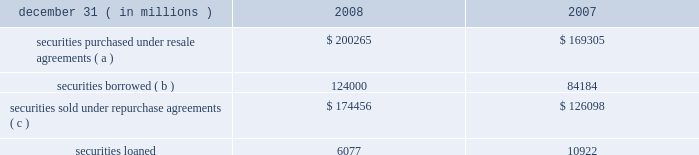Jpmorgan chase & co .
/ 2008 annual report 175jpmorgan chase & co .
/ 2008 annual report 175jpmorgan chase & co .
/ 2008 annual report 175jpmorgan chase & co .
/ 2008 annual report 175jpmorgan chase & co .
/ 2008 annual report 175 securities borrowed and securities lent are recorded at the amount of cash collateral advanced or received .
Securities borrowed consist primarily of government and equity securities .
Jpmorgan chase moni- tors the market value of the securities borrowed and lent on a daily basis and calls for additional collateral when appropriate .
Fees received or paid in connection with securities borrowed and lent are recorded in interest income or interest expense .
The table details the components of collateralized financings. .
( a ) includes resale agreements of $ 20.8 billion and $ 19.1 billion accounted for at fair value at december 31 , 2008 and 2007 , respectively .
( b ) includes securities borrowed of $ 3.4 billion accounted for at fair value at december 31 , 2008 .
( c ) includes repurchase agreements of $ 3.0 billion and $ 5.8 billion accounted for at fair value at december 31 , 2008 and 2007 , respectively .
Jpmorgan chase pledges certain financial instruments it owns to col- lateralize repurchase agreements and other securities financings .
Pledged securities that can be sold or repledged by the secured party are identified as financial instruments owned ( pledged to various parties ) on the consolidated balance sheets .
At december 31 , 2008 , the firm received securities as collateral that could be repledged , delivered or otherwise used with a fair value of approximately $ 511.9 billion .
This collateral was generally obtained under resale or securities borrowing agreements .
Of these securities , approximately $ 456.6 billion were repledged , delivered or otherwise used , generally as collateral under repurchase agreements , securities lending agreements or to cover short sales .
Note 14 2013 loans the accounting for a loan may differ based upon whether it is origi- nated or purchased and as to whether the loan is used in an invest- ing or trading strategy .
For purchased loans held-for-investment , the accounting also differs depending on whether a loan is credit- impaired at the date of acquisition .
Purchased loans with evidence of credit deterioration since the origination date and for which it is probable , at acquisition , that all contractually required payments receivable will not be collected are considered to be credit-impaired .
The measurement framework for loans in the consolidated financial statements is one of the following : 2022 at the principal amount outstanding , net of the allowance for loan losses , unearned income and any net deferred loan fees or costs , for loans held for investment ( other than purchased credit- impaired loans ) ; 2022 at the lower of cost or fair value , with valuation changes record- ed in noninterest revenue , for loans that are classified as held- for-sale ; or 2022 at fair value , with changes in fair value recorded in noninterest revenue , for loans classified as trading assets or risk managed on a fair value basis ; 2022 purchased credit-impaired loans held for investment are account- ed for under sop 03-3 and initially measured at fair value , which includes estimated future credit losses .
Accordingly , an allowance for loan losses related to these loans is not recorded at the acquisition date .
See note 5 on pages 156 2013158 of this annual report for further information on the firm 2019s elections of fair value accounting under sfas 159 .
See note 6 on pages 158 2013160 of this annual report for further information on loans carried at fair value and classified as trading assets .
For loans held for investment , other than purchased credit-impaired loans , interest income is recognized using the interest method or on a basis approximating a level rate of return over the term of the loan .
Loans within the held-for-investment portfolio that management decides to sell are transferred to the held-for-sale portfolio .
Transfers to held-for-sale are recorded at the lower of cost or fair value on the date of transfer .
Credit-related losses are charged off to the allowance for loan losses and losses due to changes in interest rates , or exchange rates , are recognized in noninterest revenue .
Loans within the held-for-sale portfolio that management decides to retain are transferred to the held-for-investment portfolio at the lower of cost or fair value .
These loans are subsequently assessed for impairment based on the firm 2019s allowance methodology .
For a fur- ther discussion of the methodologies used in establishing the firm 2019s allowance for loan losses , see note 15 on pages 178 2013180 of this annual report .
Nonaccrual loans are those on which the accrual of interest is dis- continued .
Loans ( other than certain consumer and purchased credit- impaired loans discussed below ) are placed on nonaccrual status immediately if , in the opinion of management , full payment of princi- pal or interest is in doubt , or when principal or interest is 90 days or more past due and collateral , if any , is insufficient to cover principal and interest .
Loans are charged off to the allowance for loan losses when it is highly certain that a loss has been realized .
Interest accrued but not collected at the date a loan is placed on nonaccrual status is reversed against interest income .
In addition , the amortiza- tion of net deferred loan fees is suspended .
Interest income on nonaccrual loans is recognized only to the extent it is received in cash .
However , where there is doubt regarding the ultimate col- lectibility of loan principal , all cash thereafter received is applied to reduce the carrying value of such loans ( i.e. , the cost recovery method ) .
Loans are restored to accrual status only when future pay- ments of interest and principal are reasonably assured .
Consumer loans , other than purchased credit-impaired loans , are generally charged to the allowance for loan losses upon reaching specified stages of delinquency , in accordance with the federal financial institutions examination council policy .
For example , credit card loans are charged off by the end of the month in which the account becomes 180 days past due or within 60 days from receiv- ing notification of the filing of bankruptcy , whichever is earlier .
Residential mortgage products are generally charged off to net real- izable value at no later than 180 days past due .
Other consumer .
As of december 31 , 2008 , how much of the collateral related to short sales , repo's , or securities lending agreements? 
Computations: (456.6 / 511.9)
Answer: 0.89197. 